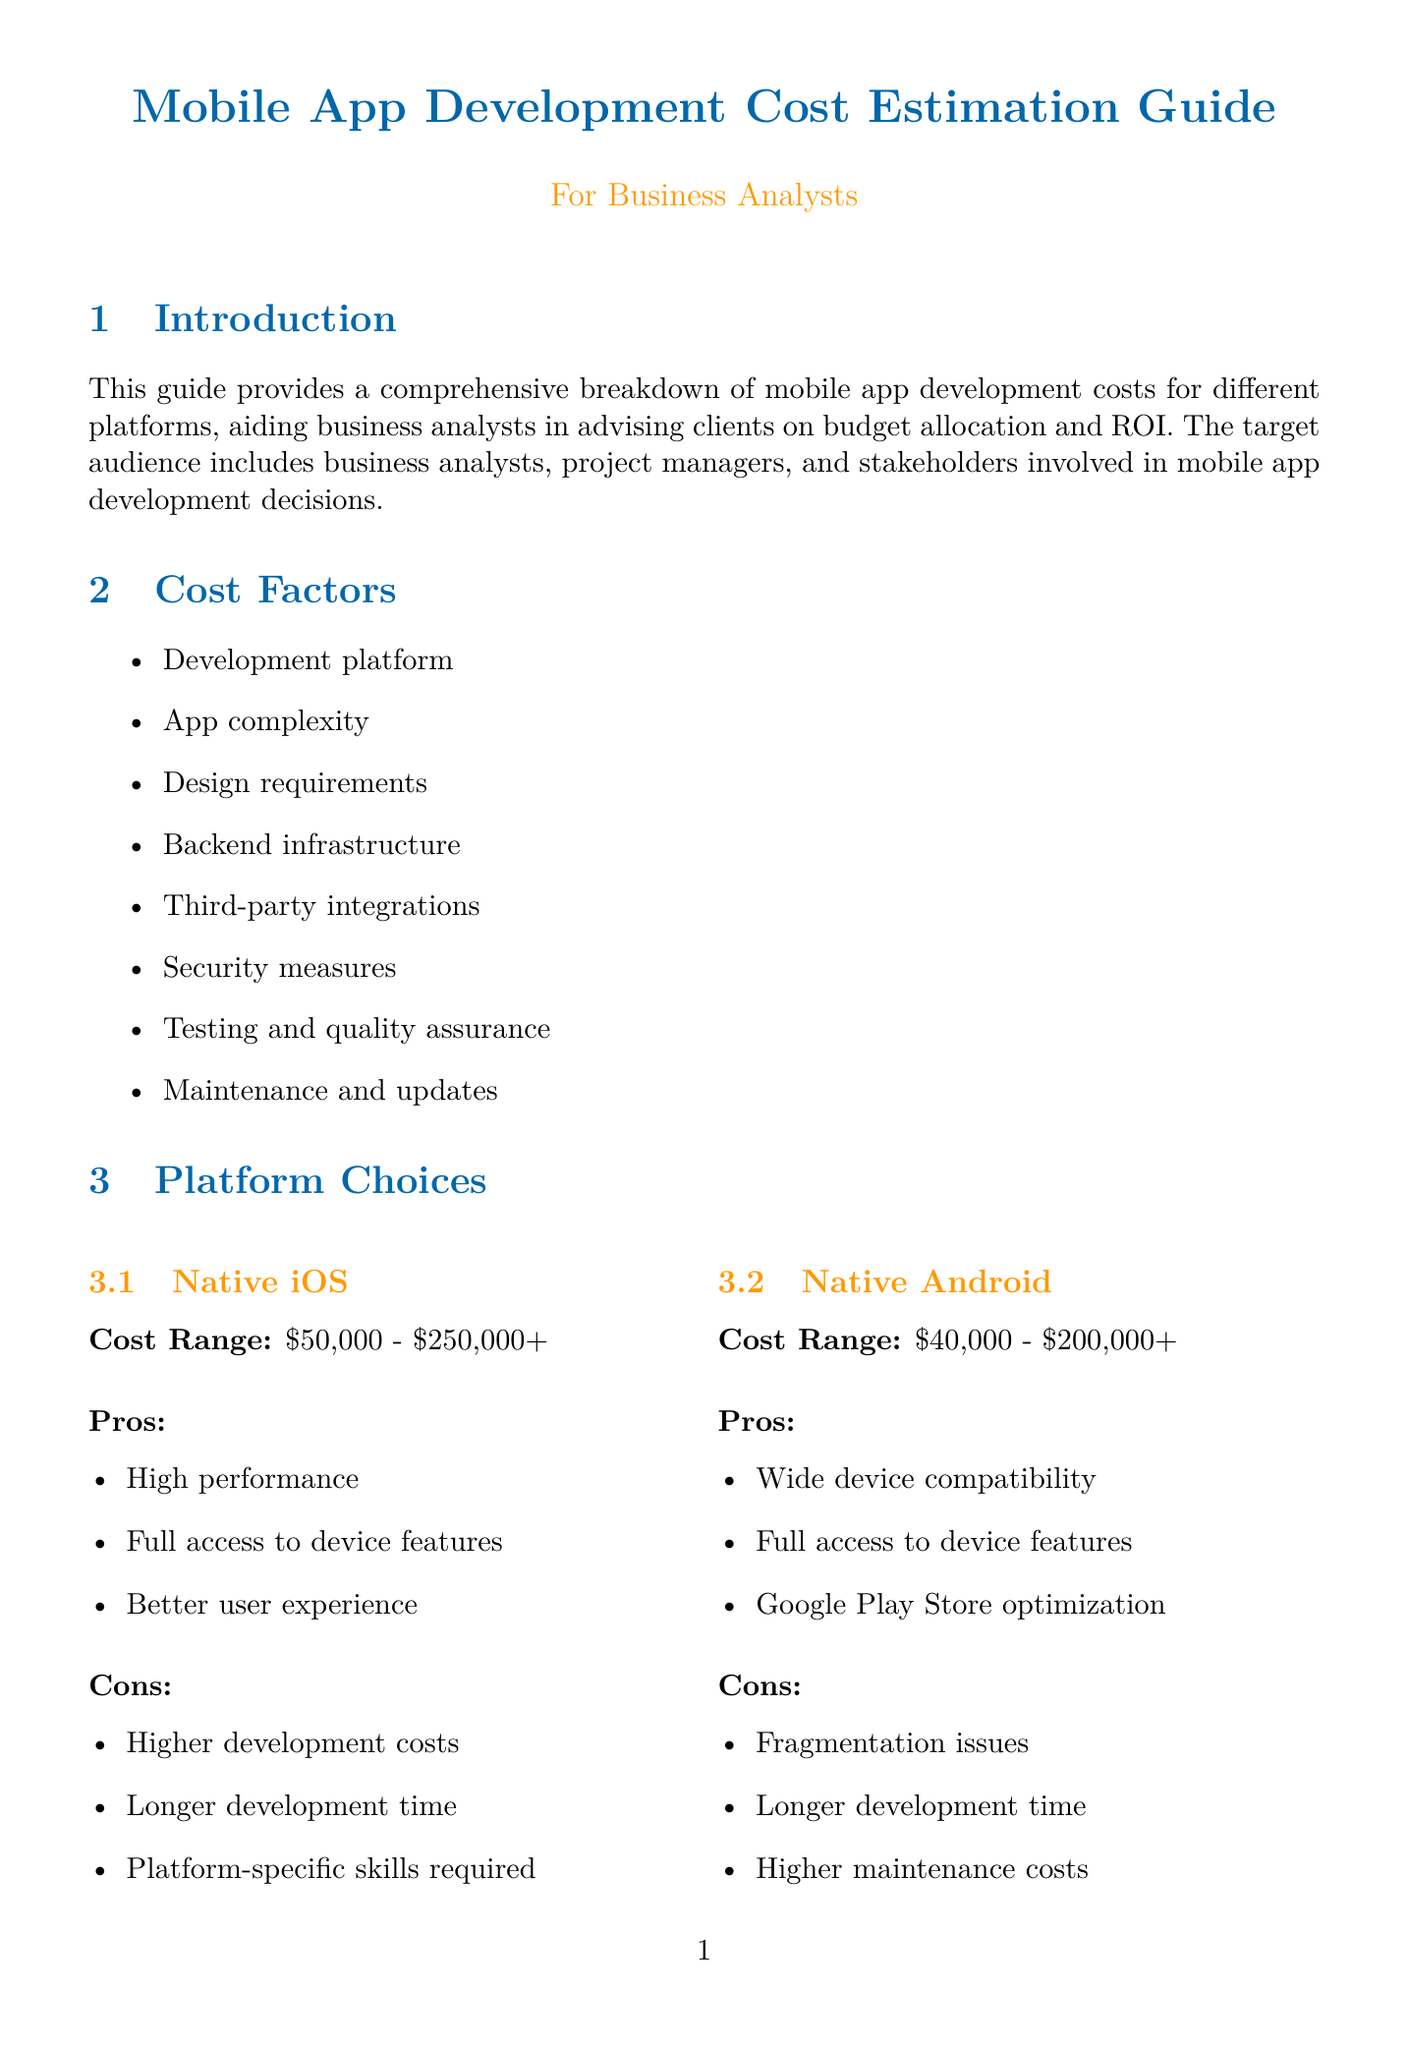what is the cost range for Native iOS development? The document specifies the development cost range which is listed under the Native iOS section.
Answer: $50,000 - $250,000+ what are the pros of using React Native? The pros are listed in the Cross-platform (React Native) section of the document.
Answer: Faster development, code reusability, cost-effective for multiple platforms what percentage of the budget should be allocated for testing and quality assurance? The percentage for testing and quality assurance can be found in the Cost Breakdown table.
Answer: 20-25% what is the initial development cost of Instagram? The initial cost is mentioned in the case studies section specific to Instagram.
Answer: $500,000 which factor relates to marketing costs in ROI considerations? This factor is explicitly named in the ROI considerations section.
Answer: User acquisition cost what is the percentage range for the Design phase? The percentage range for the Design phase is included in the Cost Breakdown table.
Answer: 15-20% what is the total time to market for Uber? The total time to market for Uber can be found in the case studies section.
Answer: 6 months which tool is a market intelligence platform? The tools are listed in the Tools and Resources section; the type helps identify the specific platform.
Answer: App Annie what is one con of Progressive Web Apps? The cons of Progressive Web Apps are detailed in the PWA section of the document.
Answer: Limited access to device features 